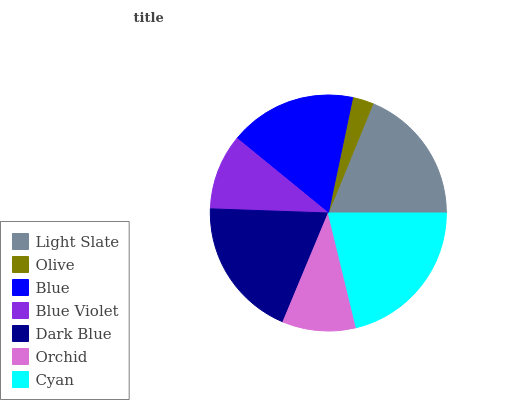Is Olive the minimum?
Answer yes or no. Yes. Is Cyan the maximum?
Answer yes or no. Yes. Is Blue the minimum?
Answer yes or no. No. Is Blue the maximum?
Answer yes or no. No. Is Blue greater than Olive?
Answer yes or no. Yes. Is Olive less than Blue?
Answer yes or no. Yes. Is Olive greater than Blue?
Answer yes or no. No. Is Blue less than Olive?
Answer yes or no. No. Is Blue the high median?
Answer yes or no. Yes. Is Blue the low median?
Answer yes or no. Yes. Is Blue Violet the high median?
Answer yes or no. No. Is Olive the low median?
Answer yes or no. No. 